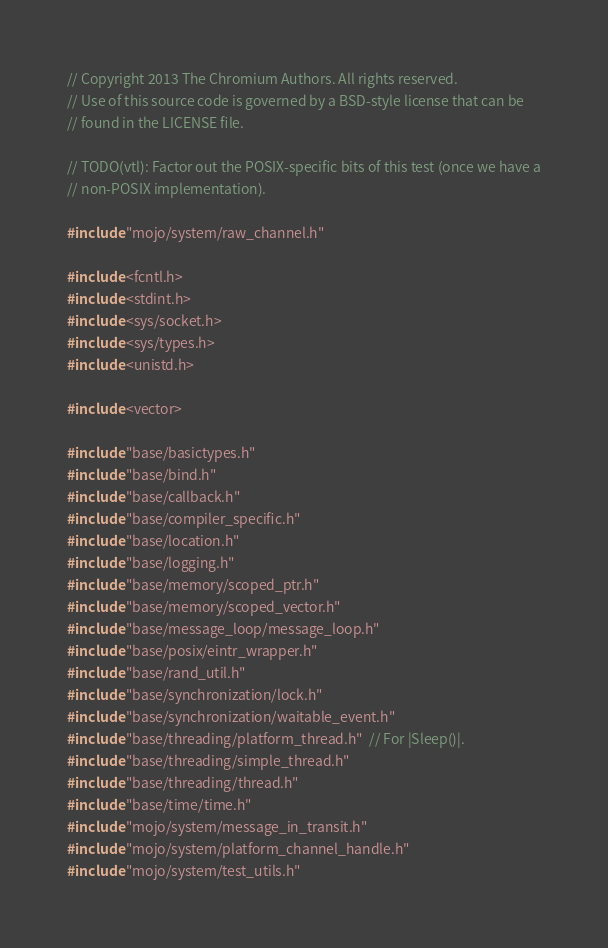Convert code to text. <code><loc_0><loc_0><loc_500><loc_500><_C++_>// Copyright 2013 The Chromium Authors. All rights reserved.
// Use of this source code is governed by a BSD-style license that can be
// found in the LICENSE file.

// TODO(vtl): Factor out the POSIX-specific bits of this test (once we have a
// non-POSIX implementation).

#include "mojo/system/raw_channel.h"

#include <fcntl.h>
#include <stdint.h>
#include <sys/socket.h>
#include <sys/types.h>
#include <unistd.h>

#include <vector>

#include "base/basictypes.h"
#include "base/bind.h"
#include "base/callback.h"
#include "base/compiler_specific.h"
#include "base/location.h"
#include "base/logging.h"
#include "base/memory/scoped_ptr.h"
#include "base/memory/scoped_vector.h"
#include "base/message_loop/message_loop.h"
#include "base/posix/eintr_wrapper.h"
#include "base/rand_util.h"
#include "base/synchronization/lock.h"
#include "base/synchronization/waitable_event.h"
#include "base/threading/platform_thread.h"  // For |Sleep()|.
#include "base/threading/simple_thread.h"
#include "base/threading/thread.h"
#include "base/time/time.h"
#include "mojo/system/message_in_transit.h"
#include "mojo/system/platform_channel_handle.h"
#include "mojo/system/test_utils.h"</code> 